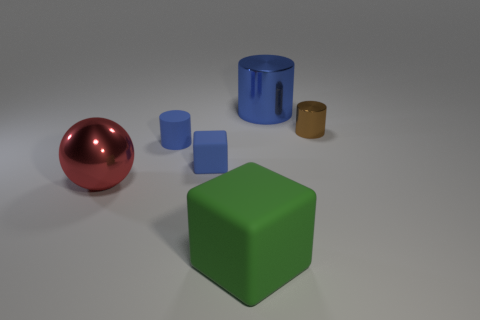Subtract all blue cylinders. How many were subtracted if there are1blue cylinders left? 1 Subtract all brown cylinders. How many cylinders are left? 2 Subtract all small cylinders. How many cylinders are left? 1 Subtract 1 cylinders. How many cylinders are left? 2 Subtract all large red metal things. Subtract all tiny blue objects. How many objects are left? 3 Add 5 blue matte blocks. How many blue matte blocks are left? 6 Add 1 small red metal blocks. How many small red metal blocks exist? 1 Add 1 blocks. How many objects exist? 7 Subtract 0 cyan cylinders. How many objects are left? 6 Subtract all balls. How many objects are left? 5 